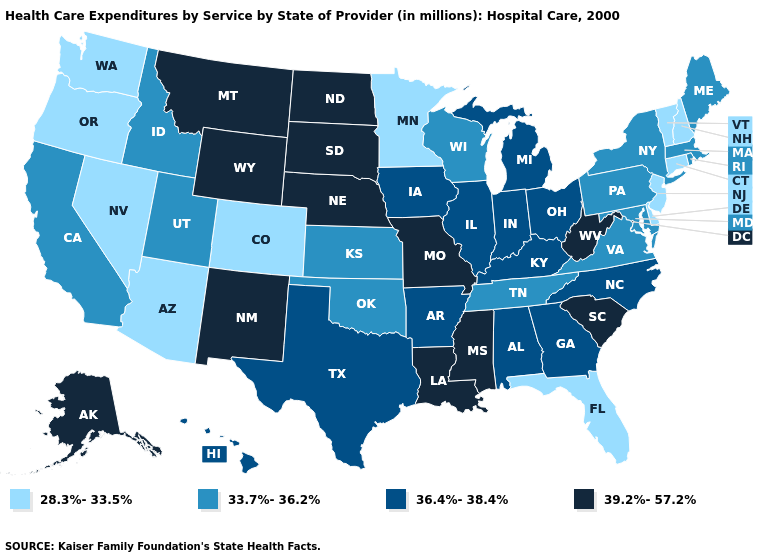Name the states that have a value in the range 33.7%-36.2%?
Give a very brief answer. California, Idaho, Kansas, Maine, Maryland, Massachusetts, New York, Oklahoma, Pennsylvania, Rhode Island, Tennessee, Utah, Virginia, Wisconsin. Does Florida have the highest value in the USA?
Be succinct. No. Does Tennessee have a lower value than Delaware?
Concise answer only. No. Name the states that have a value in the range 36.4%-38.4%?
Quick response, please. Alabama, Arkansas, Georgia, Hawaii, Illinois, Indiana, Iowa, Kentucky, Michigan, North Carolina, Ohio, Texas. What is the highest value in the MidWest ?
Short answer required. 39.2%-57.2%. Does the first symbol in the legend represent the smallest category?
Write a very short answer. Yes. Does the first symbol in the legend represent the smallest category?
Be succinct. Yes. Name the states that have a value in the range 36.4%-38.4%?
Short answer required. Alabama, Arkansas, Georgia, Hawaii, Illinois, Indiana, Iowa, Kentucky, Michigan, North Carolina, Ohio, Texas. Does Utah have the lowest value in the West?
Answer briefly. No. Does Illinois have the highest value in the MidWest?
Give a very brief answer. No. Name the states that have a value in the range 36.4%-38.4%?
Be succinct. Alabama, Arkansas, Georgia, Hawaii, Illinois, Indiana, Iowa, Kentucky, Michigan, North Carolina, Ohio, Texas. What is the highest value in the USA?
Give a very brief answer. 39.2%-57.2%. Name the states that have a value in the range 39.2%-57.2%?
Give a very brief answer. Alaska, Louisiana, Mississippi, Missouri, Montana, Nebraska, New Mexico, North Dakota, South Carolina, South Dakota, West Virginia, Wyoming. How many symbols are there in the legend?
Keep it brief. 4. What is the value of Mississippi?
Be succinct. 39.2%-57.2%. 